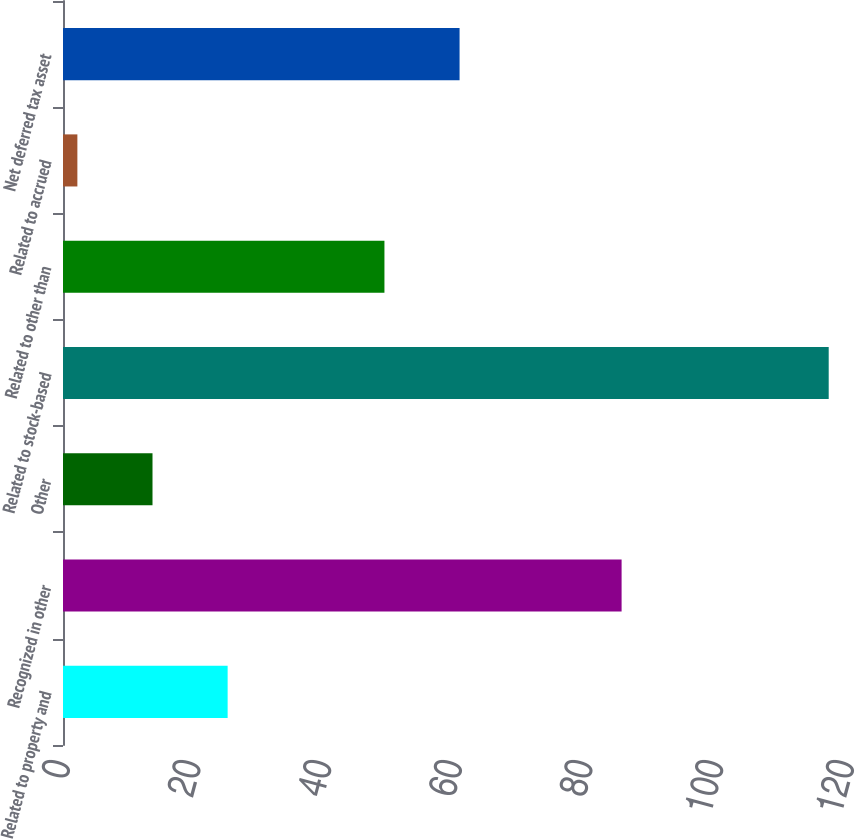Convert chart to OTSL. <chart><loc_0><loc_0><loc_500><loc_500><bar_chart><fcel>Related to property and<fcel>Recognized in other<fcel>Other<fcel>Related to stock-based<fcel>Related to other than<fcel>Related to accrued<fcel>Net deferred tax asset<nl><fcel>25.2<fcel>85.5<fcel>13.7<fcel>117.2<fcel>49.2<fcel>2.2<fcel>60.7<nl></chart> 